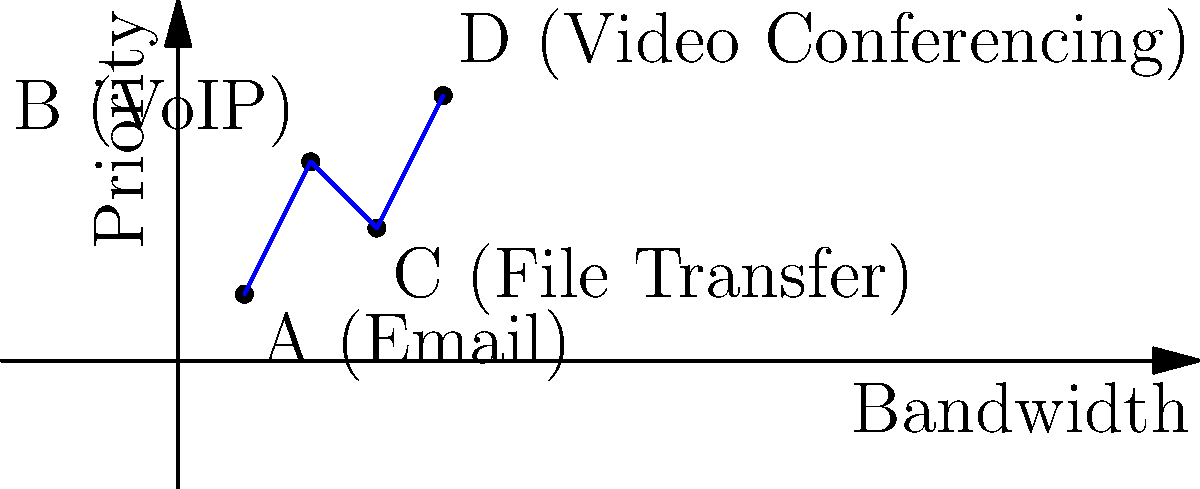In implementing QoS strategies for prioritizing critical business applications, you need to allocate bandwidth and set priorities for different types of network traffic. Given the graph showing the relationship between bandwidth allocation and priority for various applications, which application should be given the highest priority and bandwidth allocation to ensure optimal performance of critical business operations? To determine the optimal QoS strategy for critical business applications, we need to analyze the given graph and consider the importance of each application in a business context. Let's break down the analysis step-by-step:

1. Identify the applications:
   A: Email
   B: VoIP (Voice over IP)
   C: File Transfer
   D: Video Conferencing

2. Analyze the graph:
   - The x-axis represents bandwidth allocation
   - The y-axis represents priority

3. Compare the positions of each application:
   - Email (A): Low bandwidth, low priority
   - VoIP (B): Medium bandwidth, high priority
   - File Transfer (C): High bandwidth, medium priority
   - Video Conferencing (D): Highest bandwidth, highest priority

4. Consider the business impact:
   - Email is important but not real-time critical
   - VoIP requires consistent bandwidth and low latency for clear communication
   - File transfers can be scheduled and don't require real-time priority
   - Video conferencing combines audio and visual data, requiring high bandwidth and priority for smooth operation

5. Evaluate the criticality:
   Video conferencing (D) is positioned at the top-right corner of the graph, indicating it requires both the highest bandwidth allocation and the highest priority. In a business context, video conferencing is often used for important meetings, client presentations, and collaborative sessions, making it a critical application for maintaining effective communication and decision-making processes.

Given these factors, video conferencing (D) should be given the highest priority and bandwidth allocation to ensure optimal performance of critical business operations.
Answer: Video Conferencing 